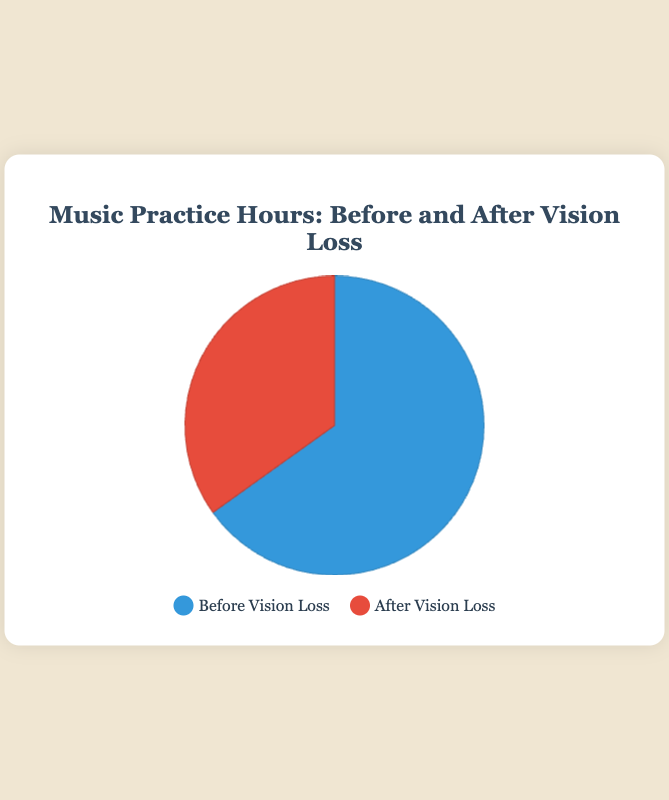How many more hours were spent practicing music before vision loss compared to after? To find the difference in hours spent practicing before and after vision loss, subtract the hours after vision loss from the hours before vision loss: 28 hours - 15 hours = 13 hours
Answer: 13 What percentage of the total practice hours was spent practicing after vision loss? First, sum the total hours spent practicing music (28 hours before + 15 hours after = 43 hours). Then, calculate the percentage for after vision loss: (15 hours / 43 hours) * 100 = 34.88%
Answer: 34.88% What is the ratio of hours spent practicing music before vision loss to hours spent after vision loss? To find the ratio, divide the hours before vision loss by the hours after vision loss: 28 hours / 15 hours = 1.87 (approximately 2:1 ratio)
Answer: 1.87 (approximately 2:1) Which time period had less practice hours? Compare the hours spent practicing before and after vision loss: 28 hours (before) and 15 hours (after). Since 15 is less than 28, the after vision loss period had fewer hours.
Answer: After vision loss What color represents the "Before Vision Loss" category in the pie chart? The legend indicates that "Before Vision Loss" is represented by the color blue in the pie chart.
Answer: Blue By how many hours did practice decrease after vision loss? To find the decrease in practice hours, calculate the difference between before and after: 28 hours (before) - 15 hours (after) = 13 hours
Answer: 13 What portion of the pie chart does the "After Vision Loss" section occupy? The "After Vision Loss" section occupies a portion equivalent to 15 hours out of a total of 43 hours practiced: 15/43 = approximately 34.88% of the pie chart
Answer: Approximately 34.88% How many total hours were spent practicing across both periods? Add the hours spent practicing before and after vision loss: 28 hours + 15 hours = 43 hours
Answer: 43 What is the difference in percentage of practice hours between the two periods? First, calculate the percentage of hours practiced before vision loss: 28/43 = 65.12%. For after vision loss: 15/43 = 34.88%. The difference in percentage is: 65.12% - 34.88% = 30.24%
Answer: 30.24% What does the red color in the chart indicate? The legend shows that the red color corresponds to the "After Vision Loss" category.
Answer: After Vision Loss 